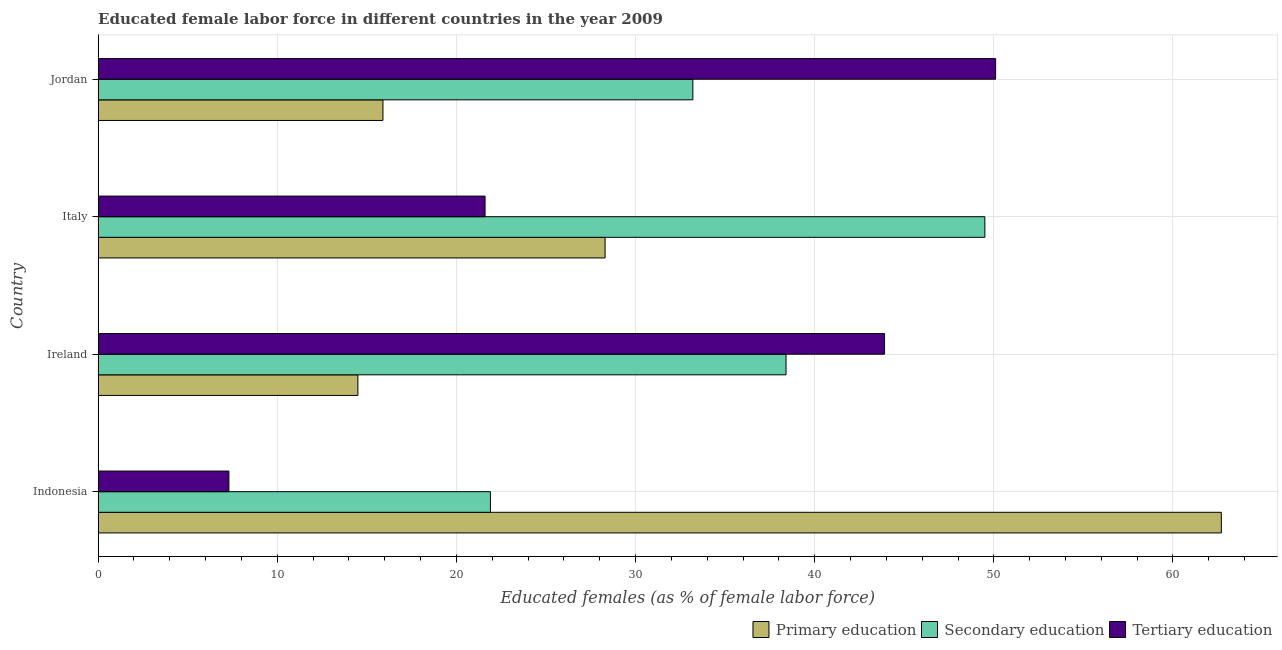How many different coloured bars are there?
Your answer should be compact. 3. How many groups of bars are there?
Make the answer very short. 4. Are the number of bars on each tick of the Y-axis equal?
Your answer should be very brief. Yes. How many bars are there on the 4th tick from the bottom?
Your response must be concise. 3. What is the label of the 4th group of bars from the top?
Keep it short and to the point. Indonesia. In how many cases, is the number of bars for a given country not equal to the number of legend labels?
Offer a very short reply. 0. What is the percentage of female labor force who received tertiary education in Indonesia?
Your answer should be compact. 7.3. Across all countries, what is the maximum percentage of female labor force who received secondary education?
Give a very brief answer. 49.5. In which country was the percentage of female labor force who received secondary education maximum?
Offer a very short reply. Italy. What is the total percentage of female labor force who received tertiary education in the graph?
Keep it short and to the point. 122.9. What is the difference between the percentage of female labor force who received tertiary education in Indonesia and the percentage of female labor force who received secondary education in Italy?
Provide a succinct answer. -42.2. What is the average percentage of female labor force who received tertiary education per country?
Your answer should be very brief. 30.73. What is the ratio of the percentage of female labor force who received tertiary education in Indonesia to that in Ireland?
Offer a very short reply. 0.17. Is the percentage of female labor force who received primary education in Ireland less than that in Italy?
Keep it short and to the point. Yes. Is the difference between the percentage of female labor force who received primary education in Indonesia and Jordan greater than the difference between the percentage of female labor force who received secondary education in Indonesia and Jordan?
Offer a terse response. Yes. What is the difference between the highest and the second highest percentage of female labor force who received secondary education?
Make the answer very short. 11.1. What is the difference between the highest and the lowest percentage of female labor force who received secondary education?
Keep it short and to the point. 27.6. Is the sum of the percentage of female labor force who received secondary education in Indonesia and Jordan greater than the maximum percentage of female labor force who received primary education across all countries?
Provide a short and direct response. No. What does the 2nd bar from the top in Italy represents?
Your response must be concise. Secondary education. What does the 1st bar from the bottom in Italy represents?
Offer a terse response. Primary education. Is it the case that in every country, the sum of the percentage of female labor force who received primary education and percentage of female labor force who received secondary education is greater than the percentage of female labor force who received tertiary education?
Your response must be concise. No. How many countries are there in the graph?
Give a very brief answer. 4. What is the difference between two consecutive major ticks on the X-axis?
Offer a terse response. 10. Are the values on the major ticks of X-axis written in scientific E-notation?
Provide a succinct answer. No. Does the graph contain grids?
Your answer should be compact. Yes. How many legend labels are there?
Make the answer very short. 3. How are the legend labels stacked?
Your answer should be compact. Horizontal. What is the title of the graph?
Give a very brief answer. Educated female labor force in different countries in the year 2009. Does "Agricultural raw materials" appear as one of the legend labels in the graph?
Ensure brevity in your answer.  No. What is the label or title of the X-axis?
Give a very brief answer. Educated females (as % of female labor force). What is the Educated females (as % of female labor force) in Primary education in Indonesia?
Keep it short and to the point. 62.7. What is the Educated females (as % of female labor force) of Secondary education in Indonesia?
Keep it short and to the point. 21.9. What is the Educated females (as % of female labor force) of Tertiary education in Indonesia?
Your answer should be very brief. 7.3. What is the Educated females (as % of female labor force) in Primary education in Ireland?
Make the answer very short. 14.5. What is the Educated females (as % of female labor force) in Secondary education in Ireland?
Make the answer very short. 38.4. What is the Educated females (as % of female labor force) of Tertiary education in Ireland?
Offer a terse response. 43.9. What is the Educated females (as % of female labor force) of Primary education in Italy?
Your answer should be very brief. 28.3. What is the Educated females (as % of female labor force) of Secondary education in Italy?
Offer a very short reply. 49.5. What is the Educated females (as % of female labor force) in Tertiary education in Italy?
Provide a short and direct response. 21.6. What is the Educated females (as % of female labor force) in Primary education in Jordan?
Provide a succinct answer. 15.9. What is the Educated females (as % of female labor force) in Secondary education in Jordan?
Provide a short and direct response. 33.2. What is the Educated females (as % of female labor force) in Tertiary education in Jordan?
Your response must be concise. 50.1. Across all countries, what is the maximum Educated females (as % of female labor force) in Primary education?
Ensure brevity in your answer.  62.7. Across all countries, what is the maximum Educated females (as % of female labor force) in Secondary education?
Provide a succinct answer. 49.5. Across all countries, what is the maximum Educated females (as % of female labor force) of Tertiary education?
Ensure brevity in your answer.  50.1. Across all countries, what is the minimum Educated females (as % of female labor force) in Secondary education?
Offer a very short reply. 21.9. Across all countries, what is the minimum Educated females (as % of female labor force) of Tertiary education?
Your response must be concise. 7.3. What is the total Educated females (as % of female labor force) of Primary education in the graph?
Keep it short and to the point. 121.4. What is the total Educated females (as % of female labor force) in Secondary education in the graph?
Offer a very short reply. 143. What is the total Educated females (as % of female labor force) of Tertiary education in the graph?
Provide a succinct answer. 122.9. What is the difference between the Educated females (as % of female labor force) in Primary education in Indonesia and that in Ireland?
Offer a terse response. 48.2. What is the difference between the Educated females (as % of female labor force) of Secondary education in Indonesia and that in Ireland?
Make the answer very short. -16.5. What is the difference between the Educated females (as % of female labor force) of Tertiary education in Indonesia and that in Ireland?
Make the answer very short. -36.6. What is the difference between the Educated females (as % of female labor force) of Primary education in Indonesia and that in Italy?
Give a very brief answer. 34.4. What is the difference between the Educated females (as % of female labor force) in Secondary education in Indonesia and that in Italy?
Your response must be concise. -27.6. What is the difference between the Educated females (as % of female labor force) of Tertiary education in Indonesia and that in Italy?
Ensure brevity in your answer.  -14.3. What is the difference between the Educated females (as % of female labor force) of Primary education in Indonesia and that in Jordan?
Keep it short and to the point. 46.8. What is the difference between the Educated females (as % of female labor force) in Secondary education in Indonesia and that in Jordan?
Make the answer very short. -11.3. What is the difference between the Educated females (as % of female labor force) of Tertiary education in Indonesia and that in Jordan?
Keep it short and to the point. -42.8. What is the difference between the Educated females (as % of female labor force) in Primary education in Ireland and that in Italy?
Make the answer very short. -13.8. What is the difference between the Educated females (as % of female labor force) in Tertiary education in Ireland and that in Italy?
Keep it short and to the point. 22.3. What is the difference between the Educated females (as % of female labor force) of Secondary education in Ireland and that in Jordan?
Offer a very short reply. 5.2. What is the difference between the Educated females (as % of female labor force) in Secondary education in Italy and that in Jordan?
Provide a succinct answer. 16.3. What is the difference between the Educated females (as % of female labor force) of Tertiary education in Italy and that in Jordan?
Provide a short and direct response. -28.5. What is the difference between the Educated females (as % of female labor force) in Primary education in Indonesia and the Educated females (as % of female labor force) in Secondary education in Ireland?
Your response must be concise. 24.3. What is the difference between the Educated females (as % of female labor force) in Primary education in Indonesia and the Educated females (as % of female labor force) in Tertiary education in Italy?
Ensure brevity in your answer.  41.1. What is the difference between the Educated females (as % of female labor force) in Secondary education in Indonesia and the Educated females (as % of female labor force) in Tertiary education in Italy?
Provide a short and direct response. 0.3. What is the difference between the Educated females (as % of female labor force) of Primary education in Indonesia and the Educated females (as % of female labor force) of Secondary education in Jordan?
Provide a short and direct response. 29.5. What is the difference between the Educated females (as % of female labor force) in Secondary education in Indonesia and the Educated females (as % of female labor force) in Tertiary education in Jordan?
Offer a very short reply. -28.2. What is the difference between the Educated females (as % of female labor force) of Primary education in Ireland and the Educated females (as % of female labor force) of Secondary education in Italy?
Give a very brief answer. -35. What is the difference between the Educated females (as % of female labor force) of Secondary education in Ireland and the Educated females (as % of female labor force) of Tertiary education in Italy?
Your response must be concise. 16.8. What is the difference between the Educated females (as % of female labor force) of Primary education in Ireland and the Educated females (as % of female labor force) of Secondary education in Jordan?
Offer a very short reply. -18.7. What is the difference between the Educated females (as % of female labor force) in Primary education in Ireland and the Educated females (as % of female labor force) in Tertiary education in Jordan?
Your answer should be compact. -35.6. What is the difference between the Educated females (as % of female labor force) of Primary education in Italy and the Educated females (as % of female labor force) of Tertiary education in Jordan?
Your answer should be very brief. -21.8. What is the difference between the Educated females (as % of female labor force) of Secondary education in Italy and the Educated females (as % of female labor force) of Tertiary education in Jordan?
Keep it short and to the point. -0.6. What is the average Educated females (as % of female labor force) in Primary education per country?
Provide a short and direct response. 30.35. What is the average Educated females (as % of female labor force) in Secondary education per country?
Offer a terse response. 35.75. What is the average Educated females (as % of female labor force) in Tertiary education per country?
Ensure brevity in your answer.  30.73. What is the difference between the Educated females (as % of female labor force) in Primary education and Educated females (as % of female labor force) in Secondary education in Indonesia?
Keep it short and to the point. 40.8. What is the difference between the Educated females (as % of female labor force) of Primary education and Educated females (as % of female labor force) of Tertiary education in Indonesia?
Your answer should be very brief. 55.4. What is the difference between the Educated females (as % of female labor force) of Secondary education and Educated females (as % of female labor force) of Tertiary education in Indonesia?
Your response must be concise. 14.6. What is the difference between the Educated females (as % of female labor force) of Primary education and Educated females (as % of female labor force) of Secondary education in Ireland?
Offer a terse response. -23.9. What is the difference between the Educated females (as % of female labor force) in Primary education and Educated females (as % of female labor force) in Tertiary education in Ireland?
Keep it short and to the point. -29.4. What is the difference between the Educated females (as % of female labor force) in Primary education and Educated females (as % of female labor force) in Secondary education in Italy?
Provide a short and direct response. -21.2. What is the difference between the Educated females (as % of female labor force) in Primary education and Educated females (as % of female labor force) in Tertiary education in Italy?
Keep it short and to the point. 6.7. What is the difference between the Educated females (as % of female labor force) of Secondary education and Educated females (as % of female labor force) of Tertiary education in Italy?
Keep it short and to the point. 27.9. What is the difference between the Educated females (as % of female labor force) in Primary education and Educated females (as % of female labor force) in Secondary education in Jordan?
Keep it short and to the point. -17.3. What is the difference between the Educated females (as % of female labor force) in Primary education and Educated females (as % of female labor force) in Tertiary education in Jordan?
Keep it short and to the point. -34.2. What is the difference between the Educated females (as % of female labor force) in Secondary education and Educated females (as % of female labor force) in Tertiary education in Jordan?
Provide a succinct answer. -16.9. What is the ratio of the Educated females (as % of female labor force) in Primary education in Indonesia to that in Ireland?
Your answer should be compact. 4.32. What is the ratio of the Educated females (as % of female labor force) of Secondary education in Indonesia to that in Ireland?
Your response must be concise. 0.57. What is the ratio of the Educated females (as % of female labor force) of Tertiary education in Indonesia to that in Ireland?
Give a very brief answer. 0.17. What is the ratio of the Educated females (as % of female labor force) of Primary education in Indonesia to that in Italy?
Give a very brief answer. 2.22. What is the ratio of the Educated females (as % of female labor force) of Secondary education in Indonesia to that in Italy?
Your answer should be very brief. 0.44. What is the ratio of the Educated females (as % of female labor force) in Tertiary education in Indonesia to that in Italy?
Ensure brevity in your answer.  0.34. What is the ratio of the Educated females (as % of female labor force) of Primary education in Indonesia to that in Jordan?
Ensure brevity in your answer.  3.94. What is the ratio of the Educated females (as % of female labor force) of Secondary education in Indonesia to that in Jordan?
Provide a short and direct response. 0.66. What is the ratio of the Educated females (as % of female labor force) of Tertiary education in Indonesia to that in Jordan?
Offer a very short reply. 0.15. What is the ratio of the Educated females (as % of female labor force) in Primary education in Ireland to that in Italy?
Offer a very short reply. 0.51. What is the ratio of the Educated females (as % of female labor force) of Secondary education in Ireland to that in Italy?
Ensure brevity in your answer.  0.78. What is the ratio of the Educated females (as % of female labor force) of Tertiary education in Ireland to that in Italy?
Make the answer very short. 2.03. What is the ratio of the Educated females (as % of female labor force) of Primary education in Ireland to that in Jordan?
Keep it short and to the point. 0.91. What is the ratio of the Educated females (as % of female labor force) of Secondary education in Ireland to that in Jordan?
Ensure brevity in your answer.  1.16. What is the ratio of the Educated females (as % of female labor force) of Tertiary education in Ireland to that in Jordan?
Your answer should be compact. 0.88. What is the ratio of the Educated females (as % of female labor force) of Primary education in Italy to that in Jordan?
Your answer should be very brief. 1.78. What is the ratio of the Educated females (as % of female labor force) in Secondary education in Italy to that in Jordan?
Offer a terse response. 1.49. What is the ratio of the Educated females (as % of female labor force) in Tertiary education in Italy to that in Jordan?
Give a very brief answer. 0.43. What is the difference between the highest and the second highest Educated females (as % of female labor force) of Primary education?
Give a very brief answer. 34.4. What is the difference between the highest and the second highest Educated females (as % of female labor force) in Tertiary education?
Your answer should be compact. 6.2. What is the difference between the highest and the lowest Educated females (as % of female labor force) of Primary education?
Provide a short and direct response. 48.2. What is the difference between the highest and the lowest Educated females (as % of female labor force) of Secondary education?
Your answer should be compact. 27.6. What is the difference between the highest and the lowest Educated females (as % of female labor force) of Tertiary education?
Your response must be concise. 42.8. 